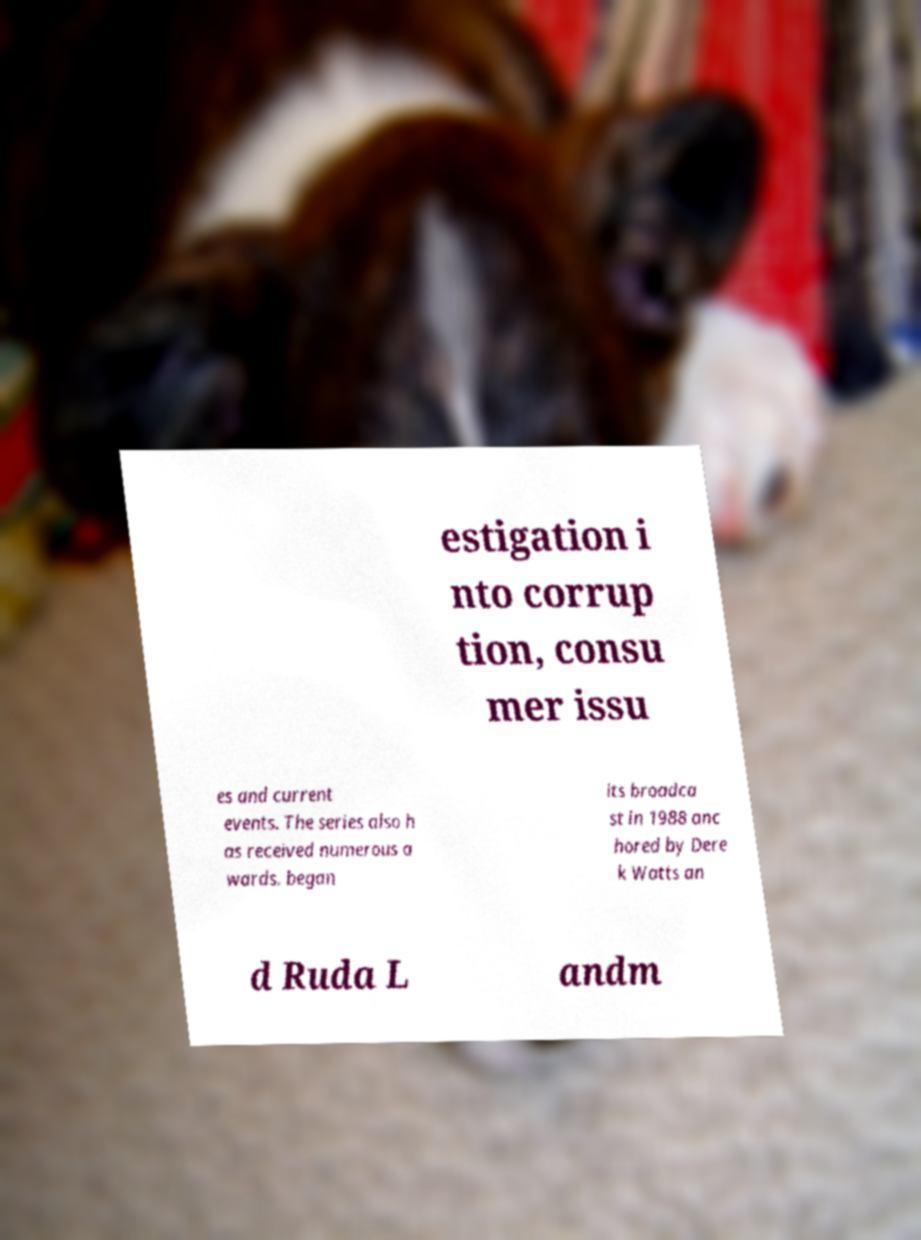Could you extract and type out the text from this image? estigation i nto corrup tion, consu mer issu es and current events. The series also h as received numerous a wards. began its broadca st in 1988 anc hored by Dere k Watts an d Ruda L andm 